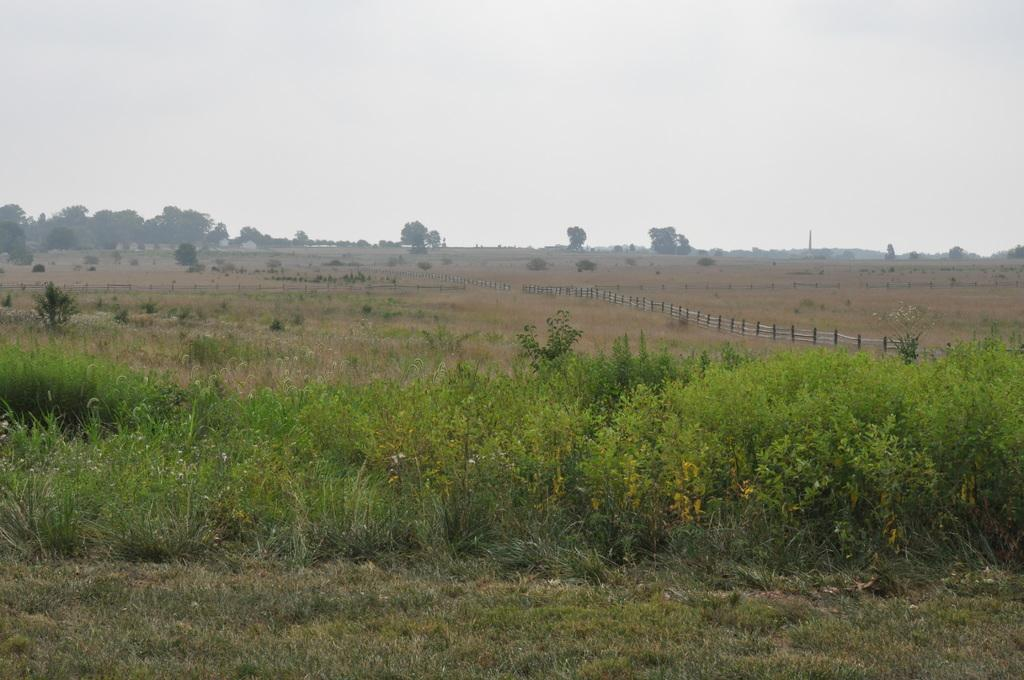What type of vegetation is present on the ground in the image? There are plants and trees on the ground in the image. What type of barrier can be seen in the image? There is a fencing in the image. What can be seen in the background of the image? There are trees and the sky visible in the background of the image. How many quarters can be seen on the ground in the image? There are no quarters present in the image. What type of laborer is working in the background of the image? There is no laborer present in the image. 